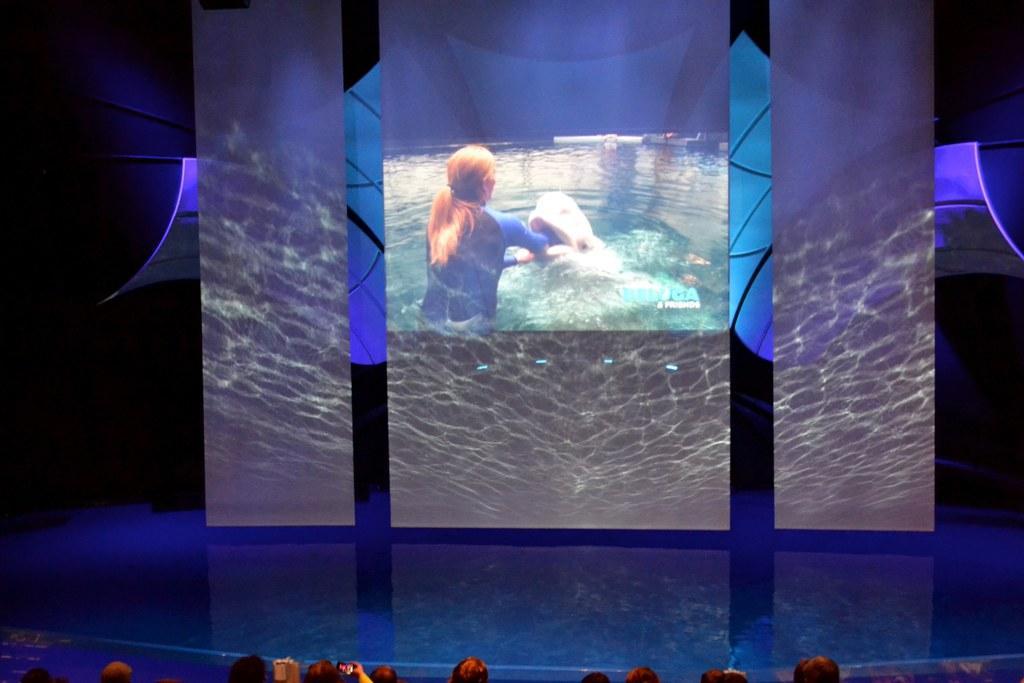Please provide a concise description of this image. In this image I can see screen and on it I can see a woman in swimming costume and a fish. I can also see few people over here. 